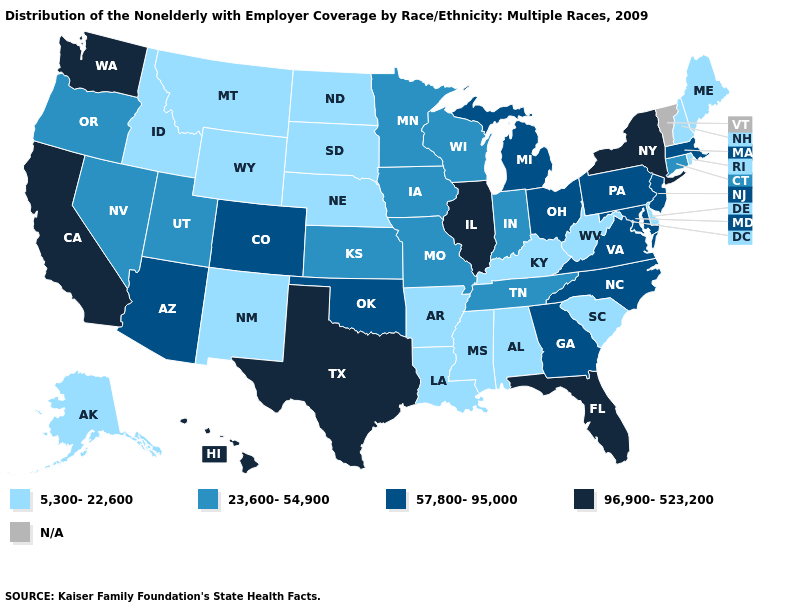What is the highest value in the USA?
Short answer required. 96,900-523,200. Name the states that have a value in the range 96,900-523,200?
Write a very short answer. California, Florida, Hawaii, Illinois, New York, Texas, Washington. Name the states that have a value in the range 57,800-95,000?
Write a very short answer. Arizona, Colorado, Georgia, Maryland, Massachusetts, Michigan, New Jersey, North Carolina, Ohio, Oklahoma, Pennsylvania, Virginia. Among the states that border Delaware , which have the lowest value?
Keep it brief. Maryland, New Jersey, Pennsylvania. What is the value of Mississippi?
Be succinct. 5,300-22,600. Name the states that have a value in the range 96,900-523,200?
Answer briefly. California, Florida, Hawaii, Illinois, New York, Texas, Washington. How many symbols are there in the legend?
Write a very short answer. 5. What is the lowest value in the USA?
Give a very brief answer. 5,300-22,600. What is the value of Ohio?
Short answer required. 57,800-95,000. What is the value of Ohio?
Short answer required. 57,800-95,000. Name the states that have a value in the range 5,300-22,600?
Keep it brief. Alabama, Alaska, Arkansas, Delaware, Idaho, Kentucky, Louisiana, Maine, Mississippi, Montana, Nebraska, New Hampshire, New Mexico, North Dakota, Rhode Island, South Carolina, South Dakota, West Virginia, Wyoming. Which states have the lowest value in the Northeast?
Keep it brief. Maine, New Hampshire, Rhode Island. Among the states that border Arkansas , does Mississippi have the lowest value?
Quick response, please. Yes. What is the value of Missouri?
Concise answer only. 23,600-54,900. 